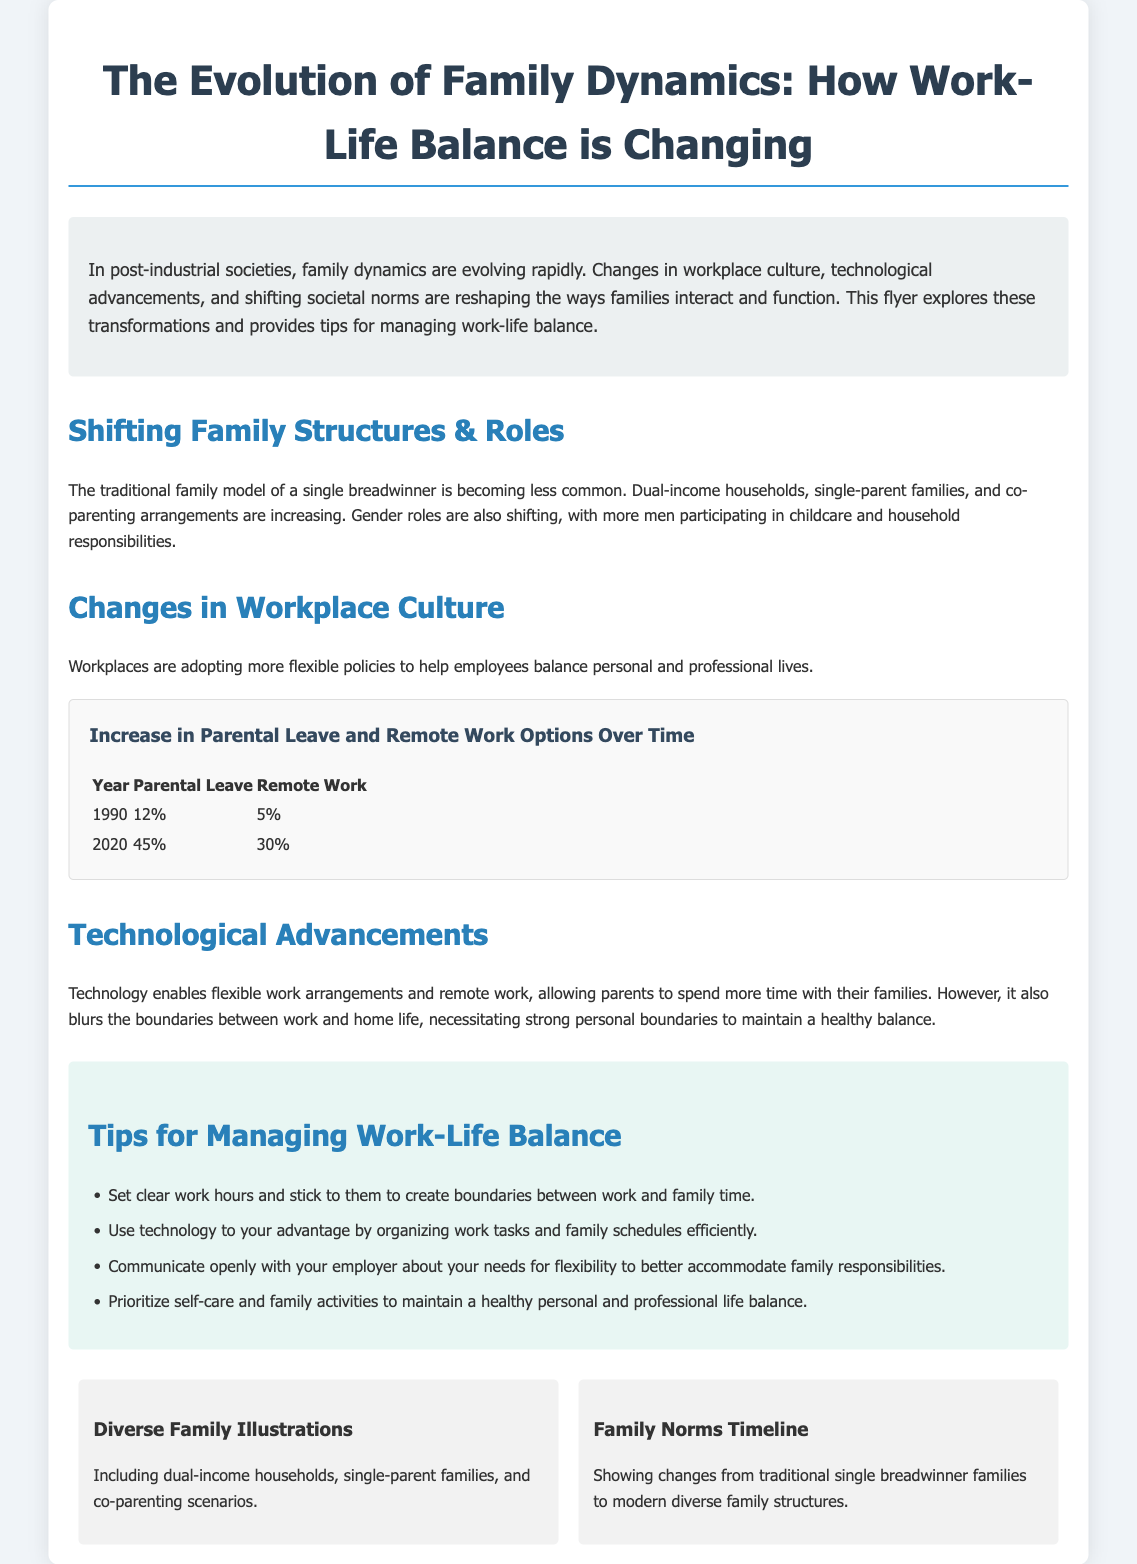What is the title of the flyer? The title is clearly stated at the top of the document.
Answer: The Evolution of Family Dynamics: How Work-Life Balance is Changing What year had a 12% rate of parental leave? The document provides specific years associated with parental leave rates.
Answer: 1990 What percentage of remote work options were available in 2020? This information is found in the chart detailing remote work options over time.
Answer: 30% What is one type of family structure that is increasing? The text discusses various family structures that are becoming more common.
Answer: Single-parent families What does the flyer suggest about setting work hours? The flyer provides advice on managing work-life balance which includes specifics about work hours.
Answer: Set clear work hours Which color is associated with the intro section of the flyer? The document describes each section's design element, including colors used in sections.
Answer: Light gray How have gender roles changed according to the flyer? The text describes evolving gender roles within the family dynamics.
Answer: More men participating in childcare What was the parental leave percentage in 2020? This specific information is highlighted in the chart provided.
Answer: 45% What visual element is used to represent diverse family compositions? The text mentions various illustrations representing family dynamics.
Answer: Diverse Family Illustrations 